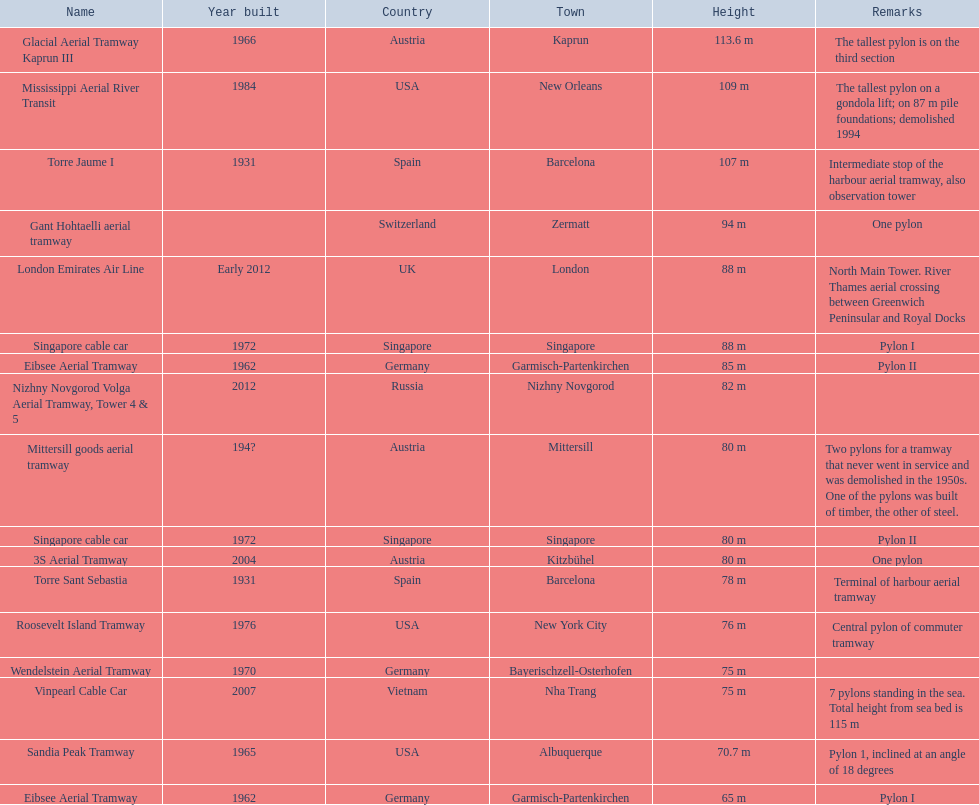Would you be able to parse every entry in this table? {'header': ['Name', 'Year built', 'Country', 'Town', 'Height', 'Remarks'], 'rows': [['Glacial Aerial Tramway Kaprun III', '1966', 'Austria', 'Kaprun', '113.6 m', 'The tallest pylon is on the third section'], ['Mississippi Aerial River Transit', '1984', 'USA', 'New Orleans', '109 m', 'The tallest pylon on a gondola lift; on 87 m pile foundations; demolished 1994'], ['Torre Jaume I', '1931', 'Spain', 'Barcelona', '107 m', 'Intermediate stop of the harbour aerial tramway, also observation tower'], ['Gant Hohtaelli aerial tramway', '', 'Switzerland', 'Zermatt', '94 m', 'One pylon'], ['London Emirates Air Line', 'Early 2012', 'UK', 'London', '88 m', 'North Main Tower. River Thames aerial crossing between Greenwich Peninsular and Royal Docks'], ['Singapore cable car', '1972', 'Singapore', 'Singapore', '88 m', 'Pylon I'], ['Eibsee Aerial Tramway', '1962', 'Germany', 'Garmisch-Partenkirchen', '85 m', 'Pylon II'], ['Nizhny Novgorod Volga Aerial Tramway, Tower 4 & 5', '2012', 'Russia', 'Nizhny Novgorod', '82 m', ''], ['Mittersill goods aerial tramway', '194?', 'Austria', 'Mittersill', '80 m', 'Two pylons for a tramway that never went in service and was demolished in the 1950s. One of the pylons was built of timber, the other of steel.'], ['Singapore cable car', '1972', 'Singapore', 'Singapore', '80 m', 'Pylon II'], ['3S Aerial Tramway', '2004', 'Austria', 'Kitzbühel', '80 m', 'One pylon'], ['Torre Sant Sebastia', '1931', 'Spain', 'Barcelona', '78 m', 'Terminal of harbour aerial tramway'], ['Roosevelt Island Tramway', '1976', 'USA', 'New York City', '76 m', 'Central pylon of commuter tramway'], ['Wendelstein Aerial Tramway', '1970', 'Germany', 'Bayerischzell-Osterhofen', '75 m', ''], ['Vinpearl Cable Car', '2007', 'Vietnam', 'Nha Trang', '75 m', '7 pylons standing in the sea. Total height from sea bed is 115 m'], ['Sandia Peak Tramway', '1965', 'USA', 'Albuquerque', '70.7 m', 'Pylon 1, inclined at an angle of 18 degrees'], ['Eibsee Aerial Tramway', '1962', 'Germany', 'Garmisch-Partenkirchen', '65 m', 'Pylon I']]} How many aerial lift pylon's on the list are located in the usa? Mississippi Aerial River Transit, Roosevelt Island Tramway, Sandia Peak Tramway. Of the pylon's located in the usa how many were built after 1970? Mississippi Aerial River Transit, Roosevelt Island Tramway. Of the pylon's built after 1970 which is the tallest pylon on a gondola lift? Mississippi Aerial River Transit. How many meters is the tallest pylon on a gondola lift? 109 m. 